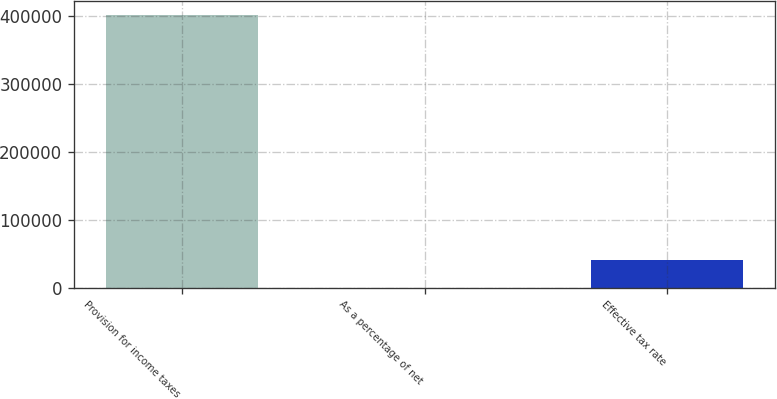Convert chart. <chart><loc_0><loc_0><loc_500><loc_500><bar_chart><fcel>Provision for income taxes<fcel>As a percentage of net<fcel>Effective tax rate<nl><fcel>402600<fcel>5.2<fcel>40264.7<nl></chart> 